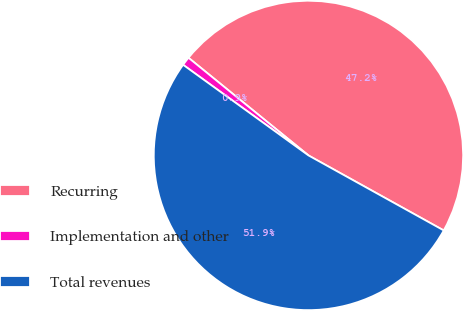Convert chart to OTSL. <chart><loc_0><loc_0><loc_500><loc_500><pie_chart><fcel>Recurring<fcel>Implementation and other<fcel>Total revenues<nl><fcel>47.18%<fcel>0.91%<fcel>51.9%<nl></chart> 